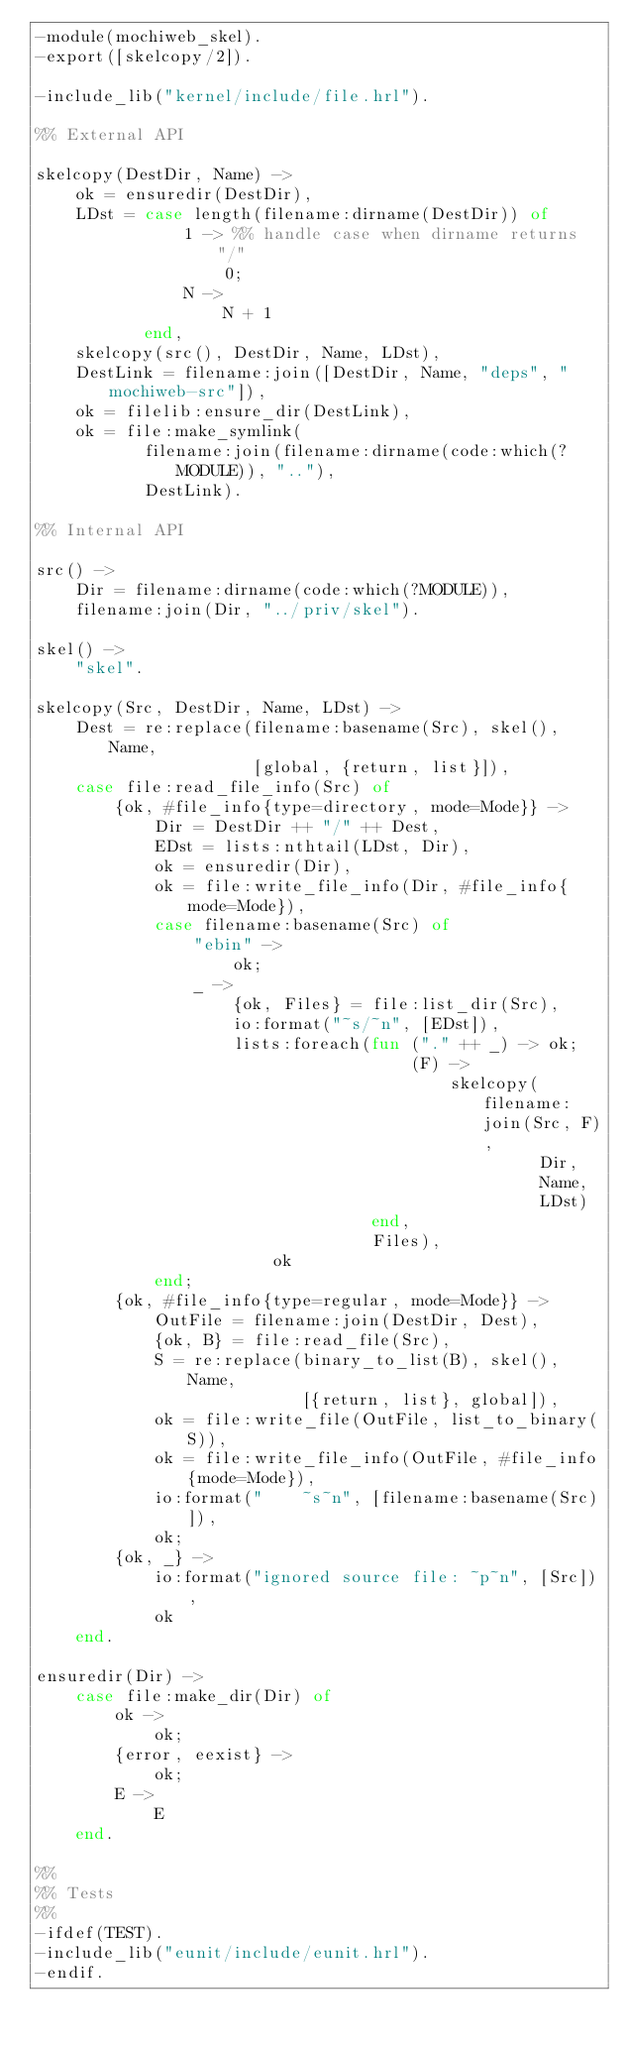Convert code to text. <code><loc_0><loc_0><loc_500><loc_500><_Erlang_>-module(mochiweb_skel).
-export([skelcopy/2]).

-include_lib("kernel/include/file.hrl").

%% External API

skelcopy(DestDir, Name) ->
    ok = ensuredir(DestDir),
    LDst = case length(filename:dirname(DestDir)) of
               1 -> %% handle case when dirname returns "/"
                   0;
               N ->
                   N + 1
           end,
    skelcopy(src(), DestDir, Name, LDst),
    DestLink = filename:join([DestDir, Name, "deps", "mochiweb-src"]),
    ok = filelib:ensure_dir(DestLink),
    ok = file:make_symlink(
           filename:join(filename:dirname(code:which(?MODULE)), ".."),
           DestLink).

%% Internal API

src() ->
    Dir = filename:dirname(code:which(?MODULE)),
    filename:join(Dir, "../priv/skel").

skel() ->
    "skel".

skelcopy(Src, DestDir, Name, LDst) ->
    Dest = re:replace(filename:basename(Src), skel(), Name,
                      [global, {return, list}]),
    case file:read_file_info(Src) of
        {ok, #file_info{type=directory, mode=Mode}} ->
            Dir = DestDir ++ "/" ++ Dest,
            EDst = lists:nthtail(LDst, Dir),
            ok = ensuredir(Dir),
            ok = file:write_file_info(Dir, #file_info{mode=Mode}),
            case filename:basename(Src) of
                "ebin" ->
                    ok;
                _ ->
                    {ok, Files} = file:list_dir(Src),
                    io:format("~s/~n", [EDst]),
                    lists:foreach(fun ("." ++ _) -> ok;
                                      (F) ->
                                          skelcopy(filename:join(Src, F),
                                                   Dir,
                                                   Name,
                                                   LDst)
                                  end,
                                  Files),
                        ok
            end;
        {ok, #file_info{type=regular, mode=Mode}} ->
            OutFile = filename:join(DestDir, Dest),
            {ok, B} = file:read_file(Src),
            S = re:replace(binary_to_list(B), skel(), Name,
                           [{return, list}, global]),
            ok = file:write_file(OutFile, list_to_binary(S)),
            ok = file:write_file_info(OutFile, #file_info{mode=Mode}),
            io:format("    ~s~n", [filename:basename(Src)]),
            ok;
        {ok, _} ->
            io:format("ignored source file: ~p~n", [Src]),
            ok
    end.

ensuredir(Dir) ->
    case file:make_dir(Dir) of
        ok ->
            ok;
        {error, eexist} ->
            ok;
        E ->
            E
    end.

%%
%% Tests
%%
-ifdef(TEST).
-include_lib("eunit/include/eunit.hrl").
-endif.
</code> 